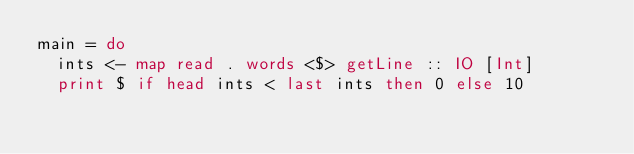<code> <loc_0><loc_0><loc_500><loc_500><_Haskell_>main = do
  ints <- map read . words <$> getLine :: IO [Int]
  print $ if head ints < last ints then 0 else 10</code> 